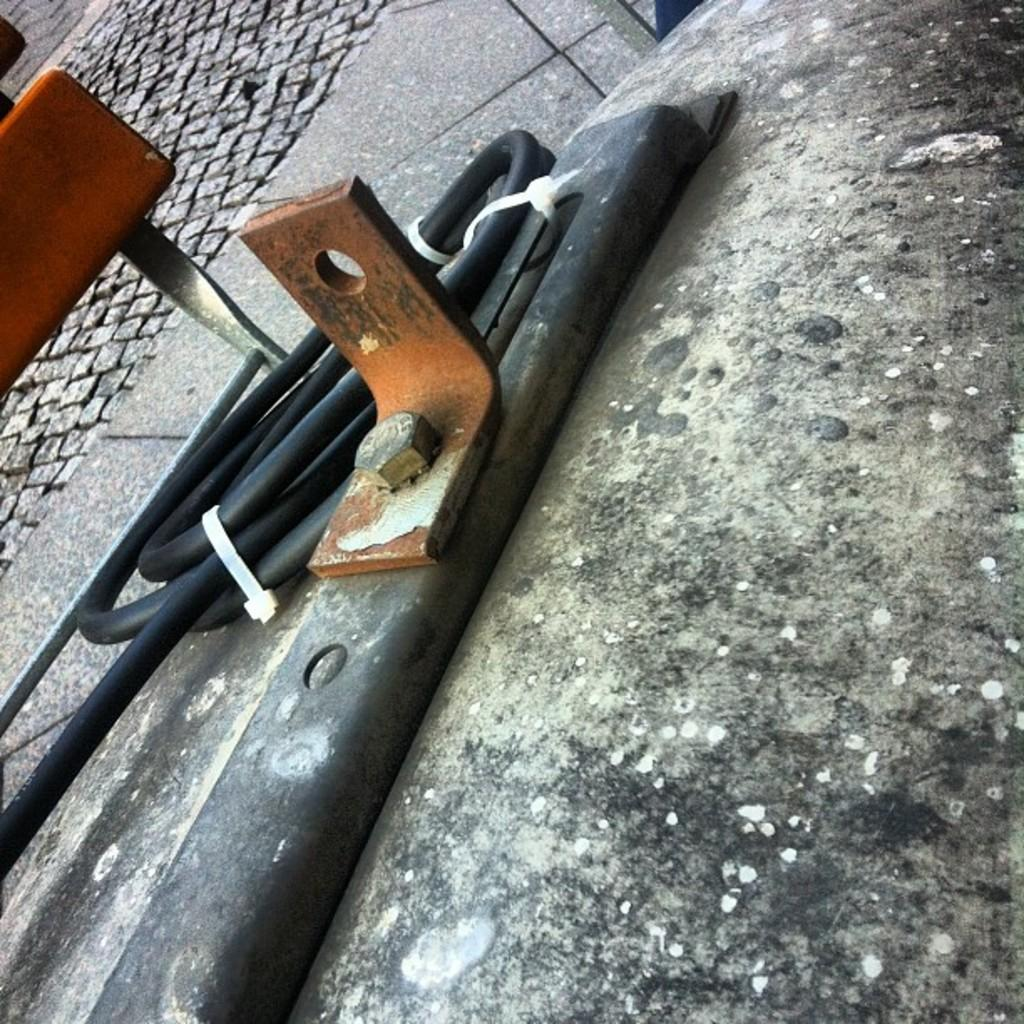What is the main setting of the image? The image depicts a street. What specific object can be seen in the image? There is a pipe in the image. Are there any other objects present in the image besides the pipe? Yes, there are other objects present in the image. What type of tin can be seen in the image? There is no tin present in the image. What rule is being followed by the objects in the image? The image does not depict any rules being followed by which the objects might be following. 